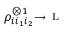Convert formula to latex. <formula><loc_0><loc_0><loc_500><loc_500>\rho _ { i i _ { 1 } i _ { 2 } } ^ { \otimes 1 } \substack { \longrightarrow \, L }</formula> 